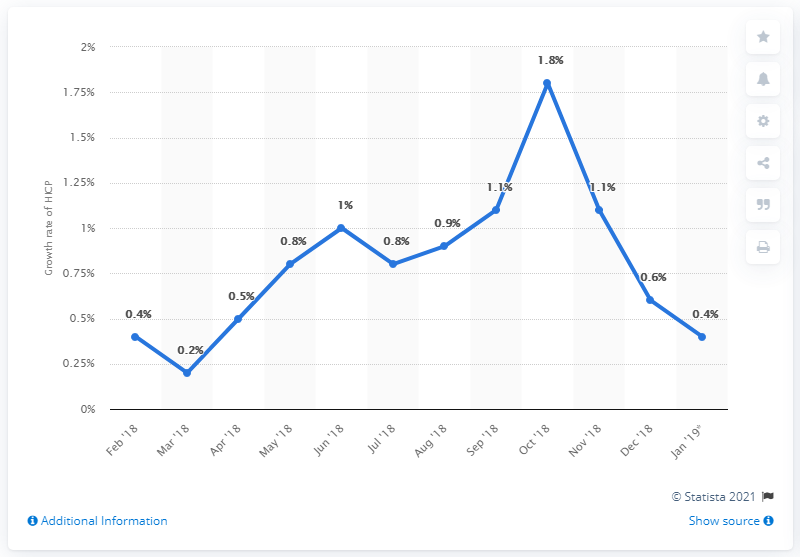Indicate a few pertinent items in this graphic. The inflation rate in December 2018 was 0.6%. 